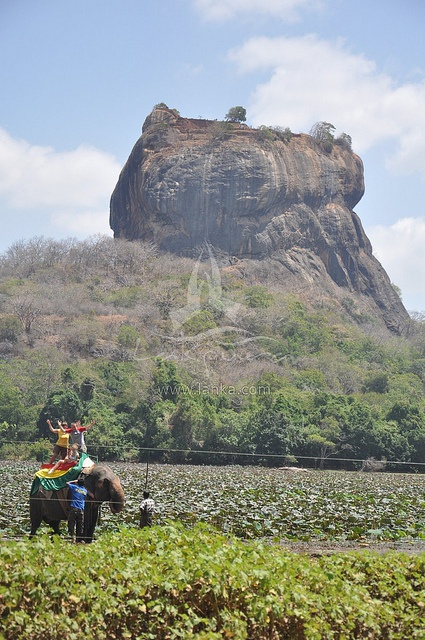Describe the objects in this image and their specific colors. I can see elephant in darkgray, black, gray, and darkgreen tones, people in darkgray, black, gray, navy, and blue tones, people in darkgray, black, gray, and lightgray tones, people in darkgray, black, maroon, gray, and olive tones, and people in darkgray, gray, tan, and white tones in this image. 